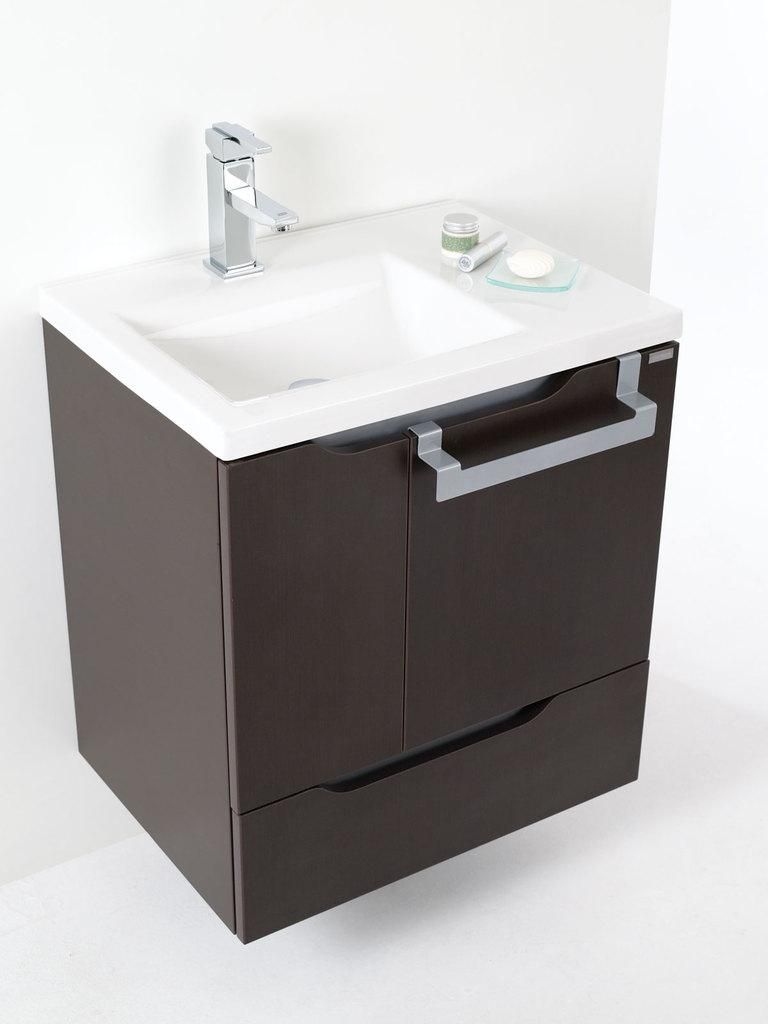What can be found in the image that is used for washing or cleaning? There is a sink in the image that can be used for washing or cleaning. What is attached to the sink for dispensing water? There is a tap on the sink for dispensing water. Where are the storage spaces located in the image? There are drawers under the sink for storage. What color is the background of the image? The background of the image is white. What type of berry is being sold at a discounted price in the image? There is no berry or price information present in the image; it features a sink with a tap and drawers. 